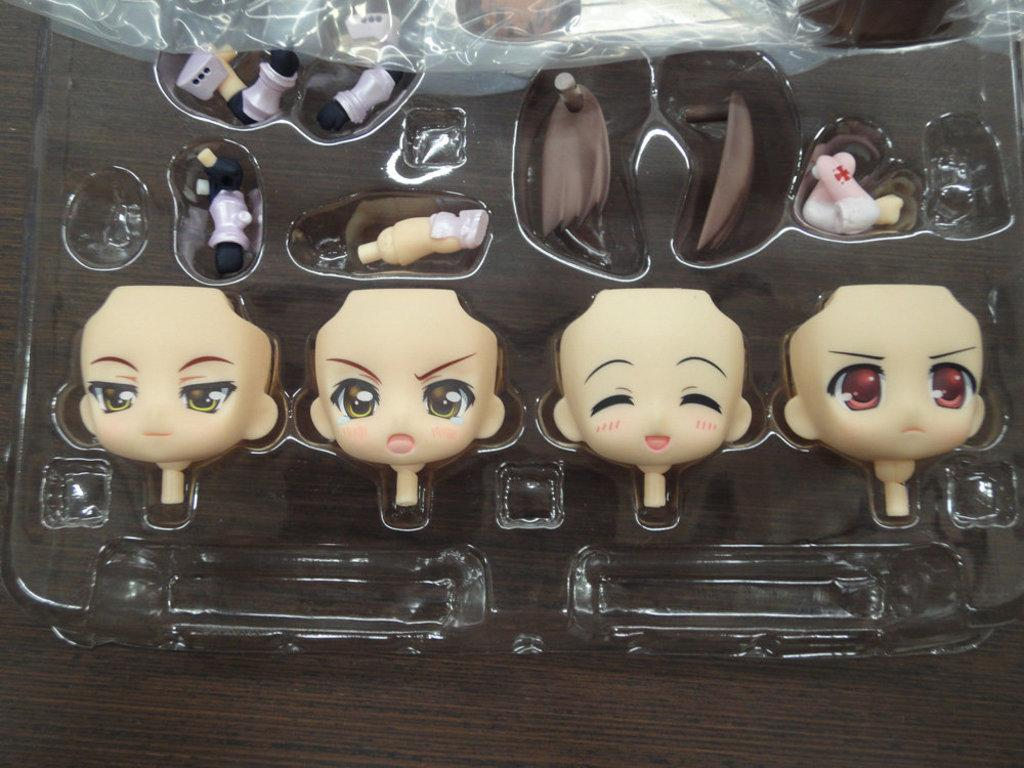What can be found inside the box in the image? There are parts of toys in the box. Where might the box be located in the image? The box might be placed on a table. What type of seashore can be seen in the image? There is no seashore present in the image; it features a box with toy parts. How does the image convey a sense of hate? The image does not convey a sense of hate; it simply shows a box with toy parts. 